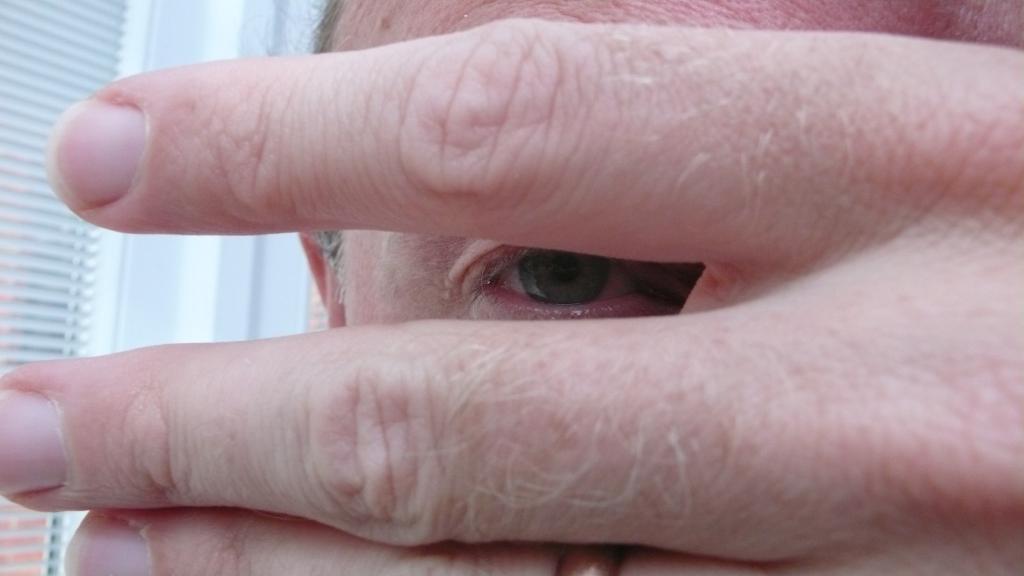Could you give a brief overview of what you see in this image? In this image we can see persons eye and fingers, also we can see a wall, and a window. 